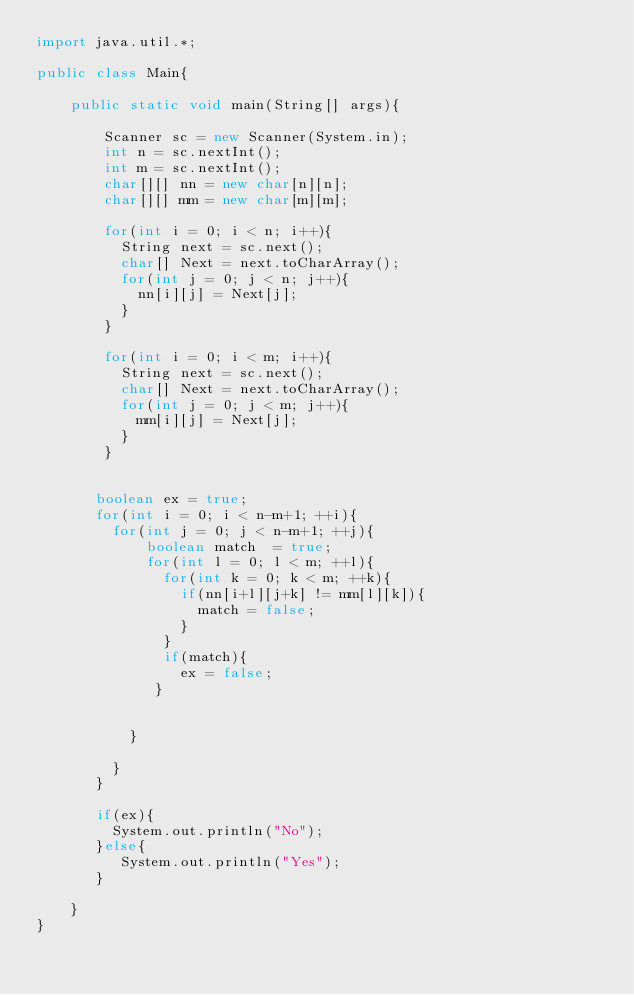Convert code to text. <code><loc_0><loc_0><loc_500><loc_500><_Java_>import java.util.*;

public class Main{

	public static void main(String[] args){

		Scanner sc = new Scanner(System.in);
        int n = sc.nextInt();
        int m = sc.nextInt();
        char[][] nn = new char[n][n];
        char[][] mm = new char[m][m];
       
        for(int i = 0; i < n; i++){
          String next = sc.next();
          char[] Next = next.toCharArray();
          for(int j = 0; j < n; j++){
            nn[i][j] = Next[j];
          }
        }
      
        for(int i = 0; i < m; i++){
          String next = sc.next();
          char[] Next = next.toCharArray();
          for(int j = 0; j < m; j++){
            mm[i][j] = Next[j];
          }
        }

      
       boolean ex = true; 
       for(int i = 0; i < n-m+1; ++i){
         for(int j = 0; j < n-m+1; ++j){
             boolean match  = true;
             for(int l = 0; l < m; ++l){
               for(int k = 0; k < m; ++k){
                 if(nn[i+l][j+k] != mm[l][k]){
                   match = false;
                 }
               }
               if(match){
                 ex = false;
              }
               
             
           }
           
         }
       }
      
       if(ex){
         System.out.println("No");
       }else{
          System.out.println("Yes");
       }

	}
}</code> 